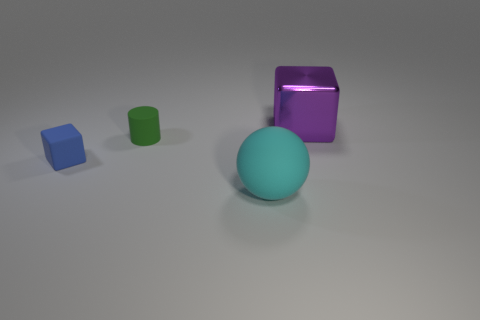There is a big object that is in front of the big object that is behind the large cyan sphere; what is its shape?
Your response must be concise. Sphere. Do the green rubber thing and the cyan object have the same shape?
Keep it short and to the point. No. Does the shiny thing have the same color as the rubber block?
Offer a very short reply. No. How many things are on the left side of the large thing that is to the left of the large thing right of the large matte object?
Provide a short and direct response. 2. There is a cyan object that is made of the same material as the small blue block; what shape is it?
Keep it short and to the point. Sphere. What is the material of the cube in front of the thing right of the large thing left of the purple shiny cube?
Your response must be concise. Rubber. What number of objects are small things to the left of the green matte cylinder or rubber cylinders?
Provide a short and direct response. 2. What number of other things are the same shape as the metal object?
Provide a short and direct response. 1. Is the number of rubber blocks in front of the cyan matte sphere greater than the number of green shiny cubes?
Provide a succinct answer. No. What is the size of the purple object that is the same shape as the blue rubber thing?
Ensure brevity in your answer.  Large. 